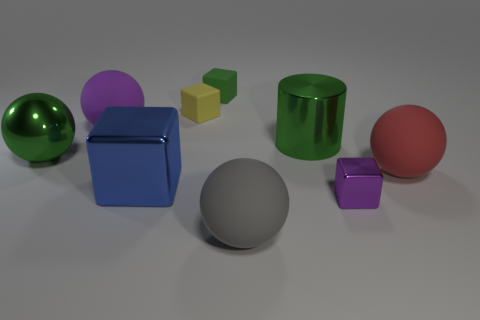Do the big shiny thing that is in front of the big red rubber thing and the small thing behind the small yellow block have the same shape?
Your response must be concise. Yes. What shape is the small object that is the same color as the big shiny cylinder?
Offer a terse response. Cube. There is a metal cube behind the tiny block that is in front of the purple rubber ball; what is its color?
Provide a succinct answer. Blue. What is the color of the other metallic object that is the same shape as the gray thing?
Ensure brevity in your answer.  Green. Is there anything else that has the same material as the yellow object?
Keep it short and to the point. Yes. There is a purple object that is the same shape as the large red rubber thing; what is its size?
Your answer should be very brief. Large. There is a small object in front of the tiny yellow block; what is it made of?
Offer a terse response. Metal. Are there fewer small yellow objects left of the green sphere than small brown rubber blocks?
Ensure brevity in your answer.  No. There is a tiny object that is in front of the sphere that is behind the large cylinder; what shape is it?
Your answer should be compact. Cube. What is the color of the large metallic cube?
Give a very brief answer. Blue. 